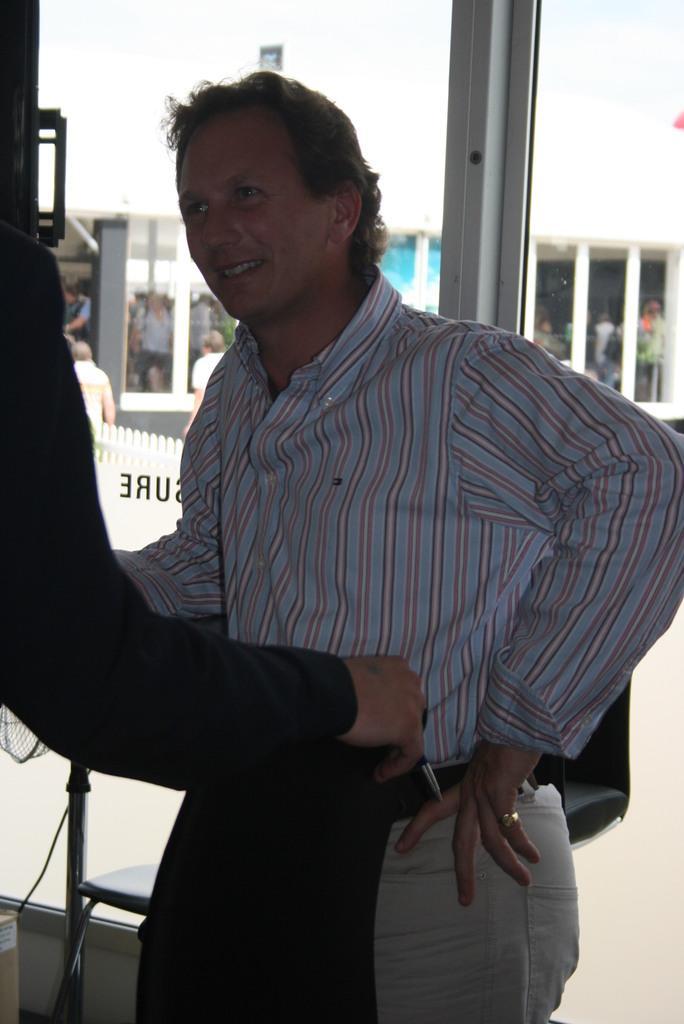Can you describe this image briefly? In this picture I can see in the middle a man is standing, he is wearing a shirt, a trouser. In the background there are glass walls and there are few people. 